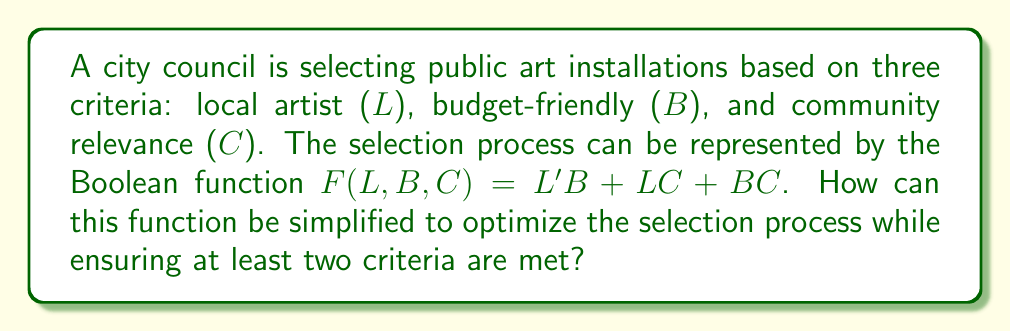Help me with this question. Let's simplify the Boolean function $F(L,B,C) = L'B + LC + BC$ step by step:

1) First, we can apply the distributive law to expand the term $BC$:
   $F(L,B,C) = L'B + LC + BC(L + L')$

2) This gives us:
   $F(L,B,C) = L'B + LC + BLC + BL'C$

3) We can now group terms with $L$ and $L'$:
   $F(L,B,C) = L(C + BC) + L'(B + BC)$

4) Simplify within the parentheses:
   $F(L,B,C) = L(C) + L'(B)$

5) This simplified form $LC + L'B$ represents:
   - Select if it's by a local artist AND community relevant, OR
   - Select if it's NOT by a local artist BUT is budget-friendly

6) This ensures that at least two criteria are always met:
   - If $L$ is true, $C$ must also be true
   - If $L$ is false, $B$ must be true

The simplified function optimizes the selection process by reducing the number of terms while still ensuring that at least two of the three criteria are satisfied for any selected art installation.
Answer: $F(L,B,C) = LC + L'B$ 